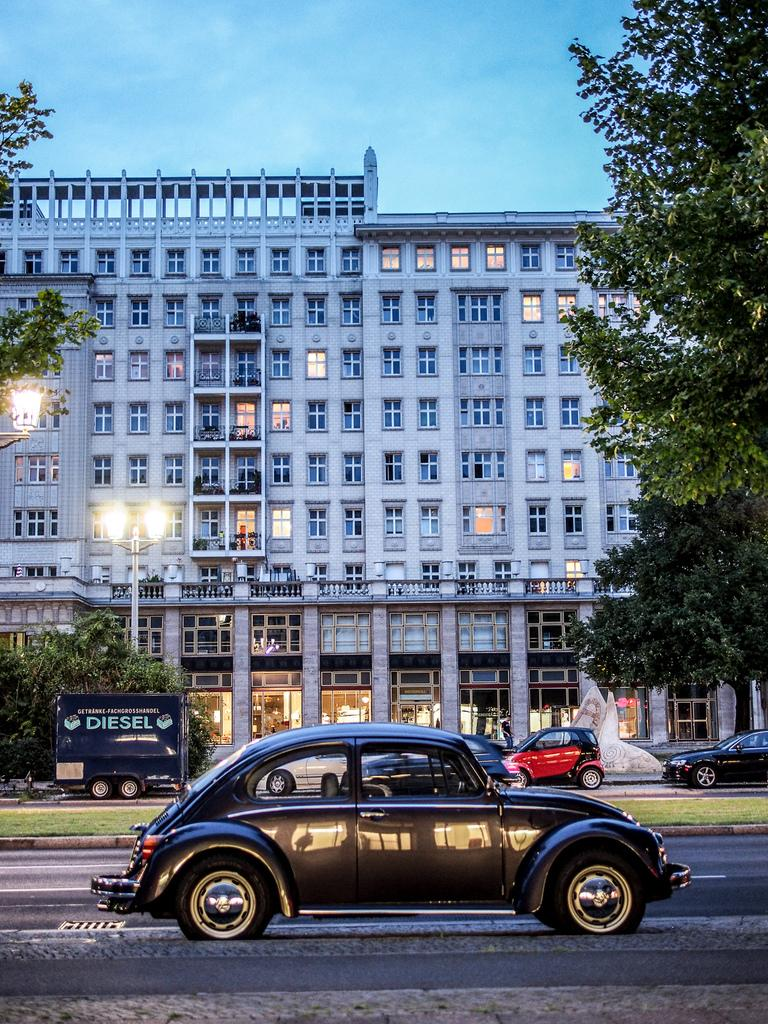What type of structures can be seen in the image? There are buildings in the image. What feature do the buildings have? The buildings have glass windows. What other elements are present in the image besides buildings? There are trees, light poles, vehicles on the road, and the sky is blue and white in color. What type of toy can be seen inside the jar in the image? There is no jar or toy present in the image. 